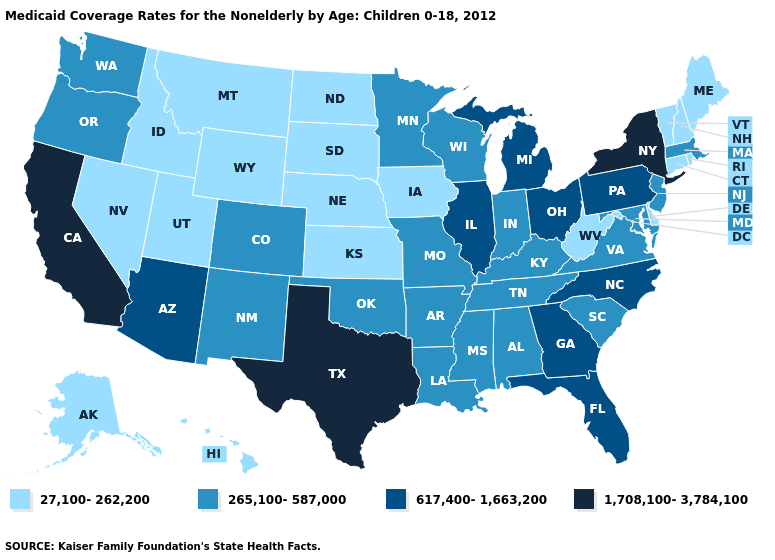Does Tennessee have a higher value than Arizona?
Give a very brief answer. No. Name the states that have a value in the range 1,708,100-3,784,100?
Write a very short answer. California, New York, Texas. Is the legend a continuous bar?
Be succinct. No. What is the value of Louisiana?
Give a very brief answer. 265,100-587,000. What is the value of Ohio?
Short answer required. 617,400-1,663,200. Does the map have missing data?
Concise answer only. No. What is the value of Missouri?
Be succinct. 265,100-587,000. Does Idaho have the lowest value in the West?
Concise answer only. Yes. Does the first symbol in the legend represent the smallest category?
Give a very brief answer. Yes. What is the value of New Jersey?
Be succinct. 265,100-587,000. Name the states that have a value in the range 617,400-1,663,200?
Short answer required. Arizona, Florida, Georgia, Illinois, Michigan, North Carolina, Ohio, Pennsylvania. What is the lowest value in the South?
Keep it brief. 27,100-262,200. Among the states that border Pennsylvania , does Ohio have the lowest value?
Write a very short answer. No. What is the value of Louisiana?
Concise answer only. 265,100-587,000. 